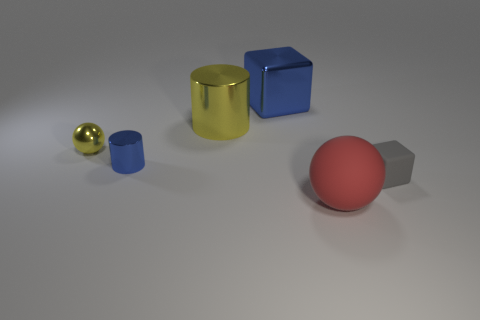There is a small shiny object right of the sphere behind the sphere right of the small blue metal cylinder; what is its color?
Provide a succinct answer. Blue. What shape is the yellow metal thing that is the same size as the red matte thing?
Your answer should be compact. Cylinder. Are there more matte spheres than big brown metallic objects?
Ensure brevity in your answer.  Yes. Is there a large yellow cylinder right of the cube in front of the large cylinder?
Offer a terse response. No. What color is the other thing that is the same shape as the large yellow shiny object?
Your response must be concise. Blue. What color is the thing that is made of the same material as the big red sphere?
Your answer should be very brief. Gray. There is a sphere on the right side of the sphere that is on the left side of the big red sphere; are there any small objects in front of it?
Ensure brevity in your answer.  No. Is the number of blue cubes that are in front of the tiny cylinder less than the number of small yellow things that are behind the big yellow cylinder?
Offer a very short reply. No. What number of red balls have the same material as the large red thing?
Ensure brevity in your answer.  0. Do the gray cube and the sphere that is on the left side of the big red ball have the same size?
Your response must be concise. Yes. 